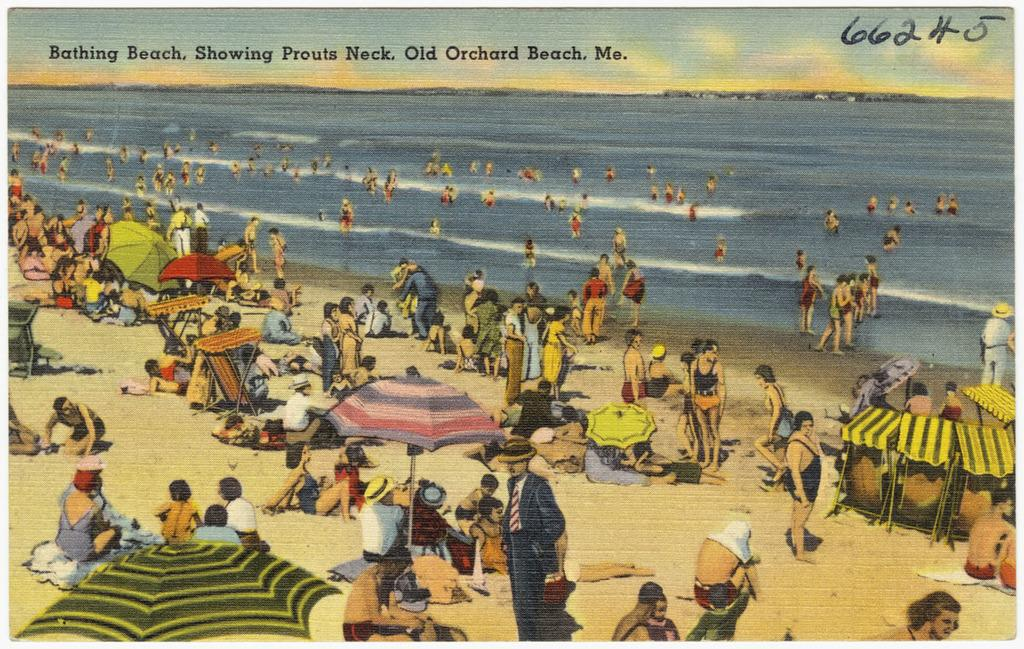<image>
Render a clear and concise summary of the photo. a photo that has the number 662 on the top right 